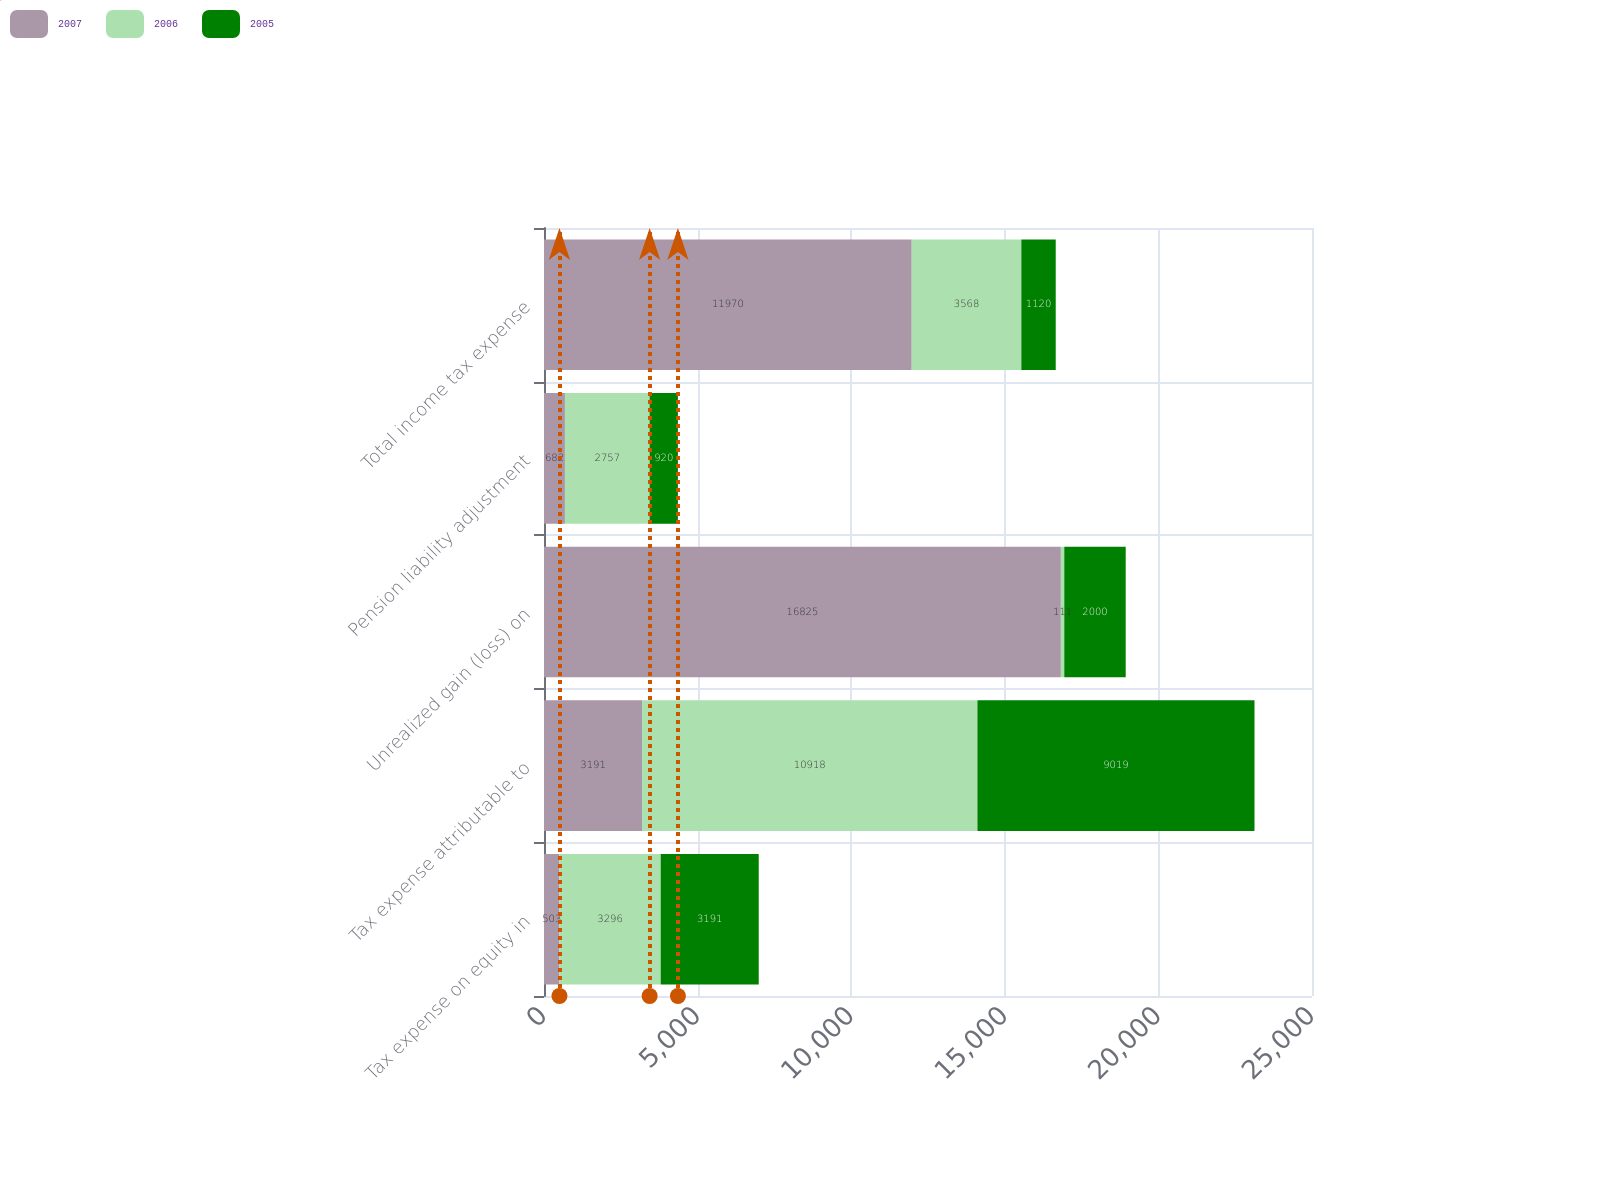<chart> <loc_0><loc_0><loc_500><loc_500><stacked_bar_chart><ecel><fcel>Tax expense on equity in<fcel>Tax expense attributable to<fcel>Unrealized gain (loss) on<fcel>Pension liability adjustment<fcel>Total income tax expense<nl><fcel>2007<fcel>503<fcel>3191<fcel>16825<fcel>682<fcel>11970<nl><fcel>2006<fcel>3296<fcel>10918<fcel>111<fcel>2757<fcel>3568<nl><fcel>2005<fcel>3191<fcel>9019<fcel>2000<fcel>920<fcel>1120<nl></chart> 